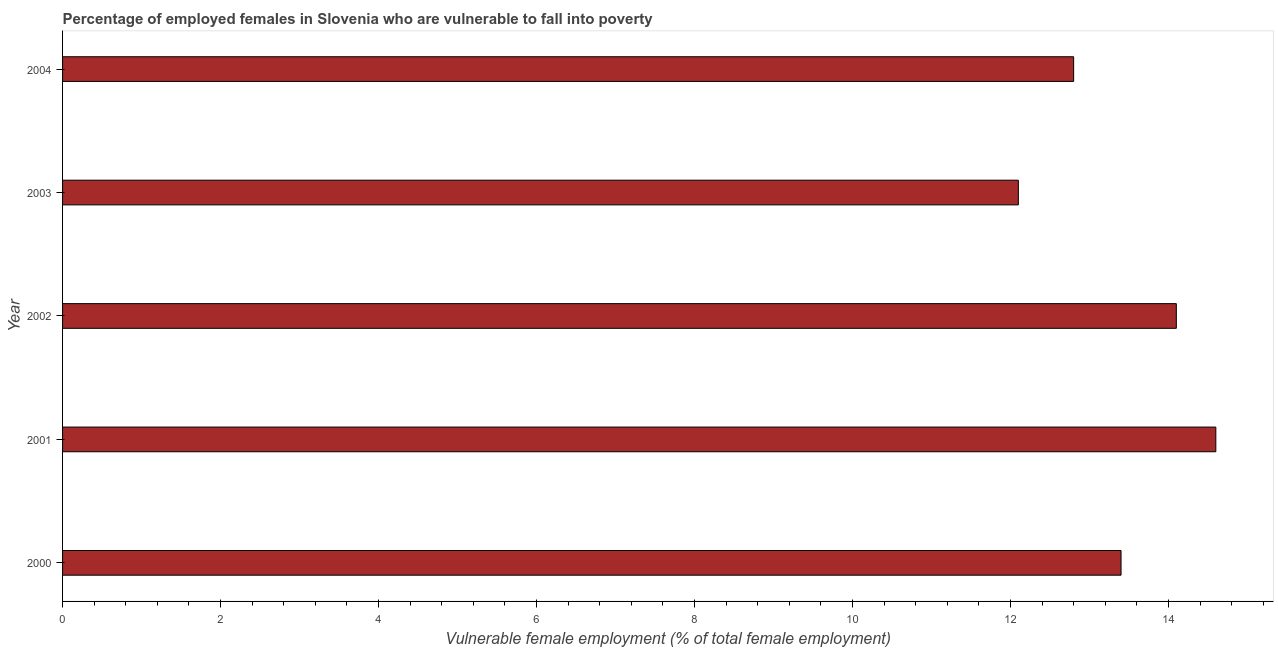Does the graph contain grids?
Your response must be concise. No. What is the title of the graph?
Make the answer very short. Percentage of employed females in Slovenia who are vulnerable to fall into poverty. What is the label or title of the X-axis?
Your answer should be very brief. Vulnerable female employment (% of total female employment). What is the percentage of employed females who are vulnerable to fall into poverty in 2002?
Offer a terse response. 14.1. Across all years, what is the maximum percentage of employed females who are vulnerable to fall into poverty?
Provide a short and direct response. 14.6. Across all years, what is the minimum percentage of employed females who are vulnerable to fall into poverty?
Provide a short and direct response. 12.1. In which year was the percentage of employed females who are vulnerable to fall into poverty maximum?
Offer a very short reply. 2001. What is the sum of the percentage of employed females who are vulnerable to fall into poverty?
Your answer should be compact. 67. What is the difference between the percentage of employed females who are vulnerable to fall into poverty in 2000 and 2001?
Make the answer very short. -1.2. What is the average percentage of employed females who are vulnerable to fall into poverty per year?
Offer a terse response. 13.4. What is the median percentage of employed females who are vulnerable to fall into poverty?
Keep it short and to the point. 13.4. In how many years, is the percentage of employed females who are vulnerable to fall into poverty greater than 14.4 %?
Make the answer very short. 1. Do a majority of the years between 2001 and 2004 (inclusive) have percentage of employed females who are vulnerable to fall into poverty greater than 0.8 %?
Offer a terse response. Yes. What is the ratio of the percentage of employed females who are vulnerable to fall into poverty in 2001 to that in 2003?
Provide a succinct answer. 1.21. Is the difference between the percentage of employed females who are vulnerable to fall into poverty in 2001 and 2002 greater than the difference between any two years?
Give a very brief answer. No. Is the sum of the percentage of employed females who are vulnerable to fall into poverty in 2002 and 2003 greater than the maximum percentage of employed females who are vulnerable to fall into poverty across all years?
Your answer should be compact. Yes. What is the difference between the highest and the lowest percentage of employed females who are vulnerable to fall into poverty?
Provide a succinct answer. 2.5. In how many years, is the percentage of employed females who are vulnerable to fall into poverty greater than the average percentage of employed females who are vulnerable to fall into poverty taken over all years?
Give a very brief answer. 2. How many bars are there?
Your answer should be very brief. 5. How many years are there in the graph?
Give a very brief answer. 5. Are the values on the major ticks of X-axis written in scientific E-notation?
Your answer should be compact. No. What is the Vulnerable female employment (% of total female employment) of 2000?
Keep it short and to the point. 13.4. What is the Vulnerable female employment (% of total female employment) in 2001?
Give a very brief answer. 14.6. What is the Vulnerable female employment (% of total female employment) of 2002?
Your answer should be compact. 14.1. What is the Vulnerable female employment (% of total female employment) in 2003?
Give a very brief answer. 12.1. What is the Vulnerable female employment (% of total female employment) of 2004?
Provide a succinct answer. 12.8. What is the difference between the Vulnerable female employment (% of total female employment) in 2000 and 2001?
Provide a short and direct response. -1.2. What is the difference between the Vulnerable female employment (% of total female employment) in 2000 and 2003?
Ensure brevity in your answer.  1.3. What is the difference between the Vulnerable female employment (% of total female employment) in 2000 and 2004?
Provide a short and direct response. 0.6. What is the difference between the Vulnerable female employment (% of total female employment) in 2002 and 2004?
Ensure brevity in your answer.  1.3. What is the difference between the Vulnerable female employment (% of total female employment) in 2003 and 2004?
Give a very brief answer. -0.7. What is the ratio of the Vulnerable female employment (% of total female employment) in 2000 to that in 2001?
Your response must be concise. 0.92. What is the ratio of the Vulnerable female employment (% of total female employment) in 2000 to that in 2002?
Provide a succinct answer. 0.95. What is the ratio of the Vulnerable female employment (% of total female employment) in 2000 to that in 2003?
Your answer should be compact. 1.11. What is the ratio of the Vulnerable female employment (% of total female employment) in 2000 to that in 2004?
Give a very brief answer. 1.05. What is the ratio of the Vulnerable female employment (% of total female employment) in 2001 to that in 2002?
Keep it short and to the point. 1.03. What is the ratio of the Vulnerable female employment (% of total female employment) in 2001 to that in 2003?
Make the answer very short. 1.21. What is the ratio of the Vulnerable female employment (% of total female employment) in 2001 to that in 2004?
Your response must be concise. 1.14. What is the ratio of the Vulnerable female employment (% of total female employment) in 2002 to that in 2003?
Make the answer very short. 1.17. What is the ratio of the Vulnerable female employment (% of total female employment) in 2002 to that in 2004?
Ensure brevity in your answer.  1.1. What is the ratio of the Vulnerable female employment (% of total female employment) in 2003 to that in 2004?
Provide a short and direct response. 0.94. 